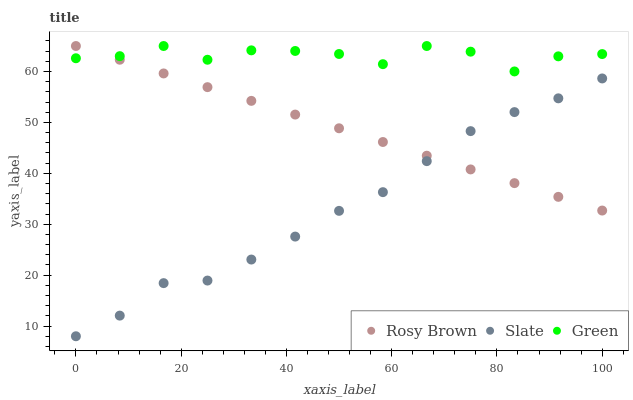Does Slate have the minimum area under the curve?
Answer yes or no. Yes. Does Green have the maximum area under the curve?
Answer yes or no. Yes. Does Rosy Brown have the minimum area under the curve?
Answer yes or no. No. Does Rosy Brown have the maximum area under the curve?
Answer yes or no. No. Is Rosy Brown the smoothest?
Answer yes or no. Yes. Is Green the roughest?
Answer yes or no. Yes. Is Green the smoothest?
Answer yes or no. No. Is Rosy Brown the roughest?
Answer yes or no. No. Does Slate have the lowest value?
Answer yes or no. Yes. Does Rosy Brown have the lowest value?
Answer yes or no. No. Does Green have the highest value?
Answer yes or no. Yes. Is Slate less than Green?
Answer yes or no. Yes. Is Green greater than Slate?
Answer yes or no. Yes. Does Rosy Brown intersect Green?
Answer yes or no. Yes. Is Rosy Brown less than Green?
Answer yes or no. No. Is Rosy Brown greater than Green?
Answer yes or no. No. Does Slate intersect Green?
Answer yes or no. No. 